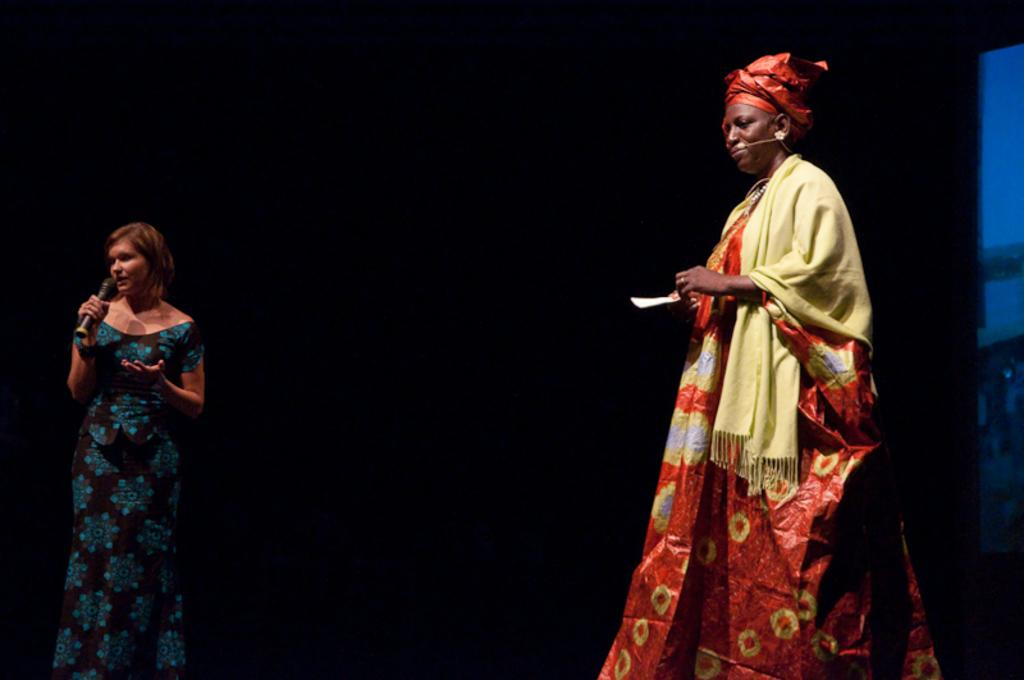How many women are present in the image? There are two women in the image. Can you describe the position of the woman on the left side? The woman on the left side is standing. What is the woman on the left side holding? The woman on the left side is holding a microphone. What can be seen on the woman on the right side? The woman on the right side is wearing a scarf. How many dust particles can be seen on the women's clothes in the image? There is no information about dust particles on the women's clothes in the image, so it cannot be determined. 